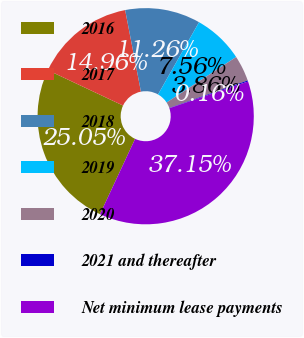Convert chart to OTSL. <chart><loc_0><loc_0><loc_500><loc_500><pie_chart><fcel>2016<fcel>2017<fcel>2018<fcel>2019<fcel>2020<fcel>2021 and thereafter<fcel>Net minimum lease payments<nl><fcel>25.06%<fcel>14.96%<fcel>11.26%<fcel>7.56%<fcel>3.86%<fcel>0.16%<fcel>37.16%<nl></chart> 